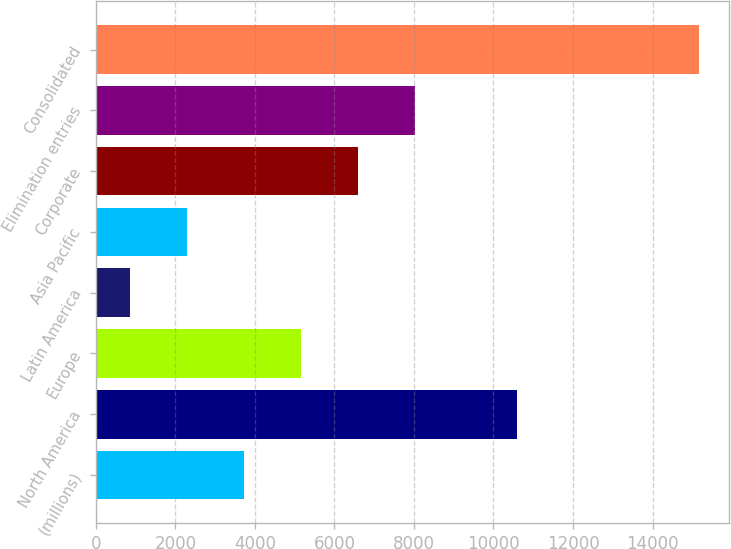Convert chart. <chart><loc_0><loc_0><loc_500><loc_500><bar_chart><fcel>(millions)<fcel>North America<fcel>Europe<fcel>Latin America<fcel>Asia Pacific<fcel>Corporate<fcel>Elimination entries<fcel>Consolidated<nl><fcel>3722.6<fcel>10602<fcel>5153.4<fcel>861<fcel>2291.8<fcel>6584.2<fcel>8015<fcel>15169<nl></chart> 